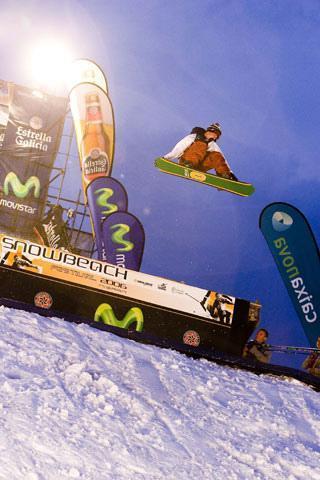How many elephants are there?
Give a very brief answer. 0. 